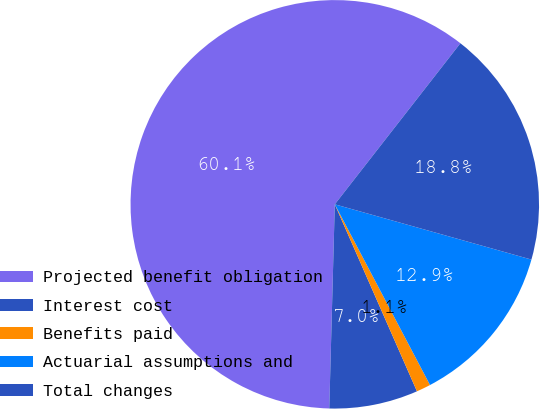Convert chart. <chart><loc_0><loc_0><loc_500><loc_500><pie_chart><fcel>Projected benefit obligation<fcel>Interest cost<fcel>Benefits paid<fcel>Actuarial assumptions and<fcel>Total changes<nl><fcel>60.11%<fcel>7.02%<fcel>1.13%<fcel>12.92%<fcel>18.82%<nl></chart> 